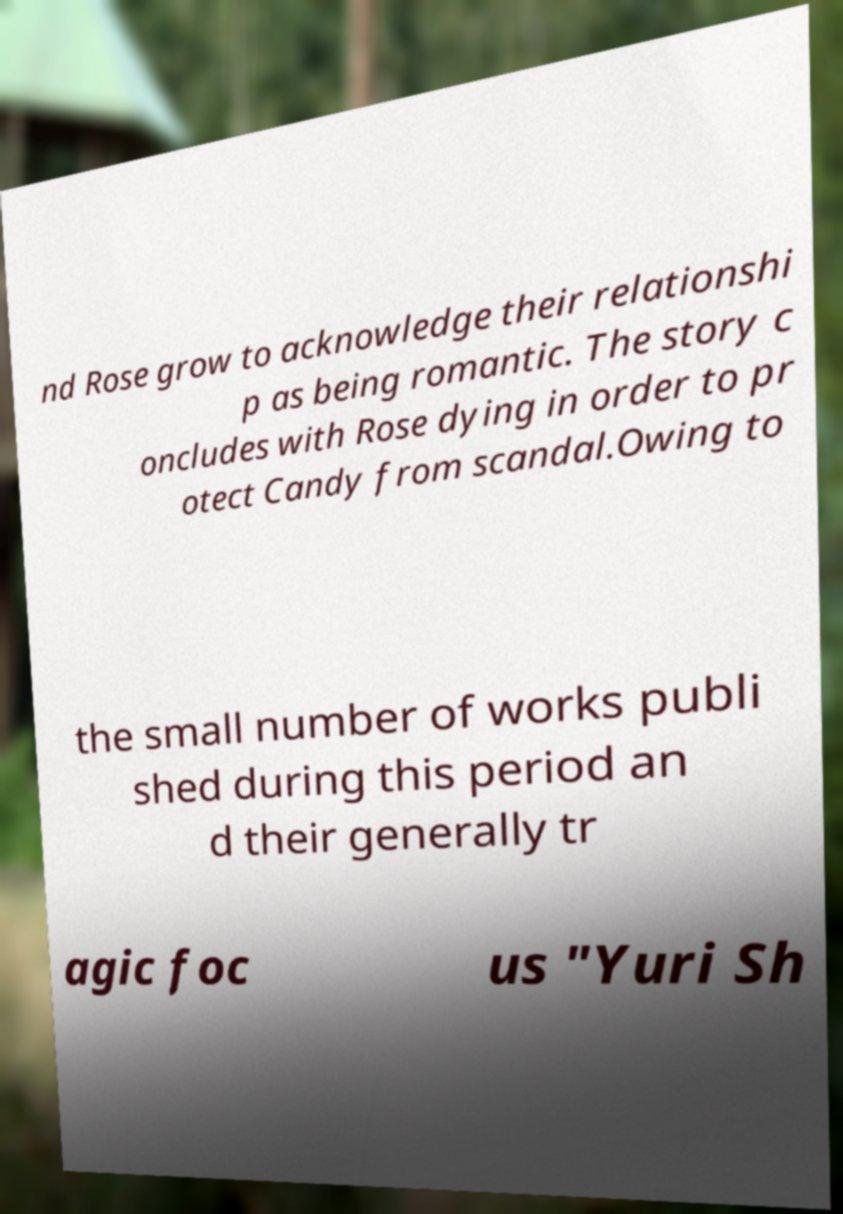Please identify and transcribe the text found in this image. nd Rose grow to acknowledge their relationshi p as being romantic. The story c oncludes with Rose dying in order to pr otect Candy from scandal.Owing to the small number of works publi shed during this period an d their generally tr agic foc us "Yuri Sh 